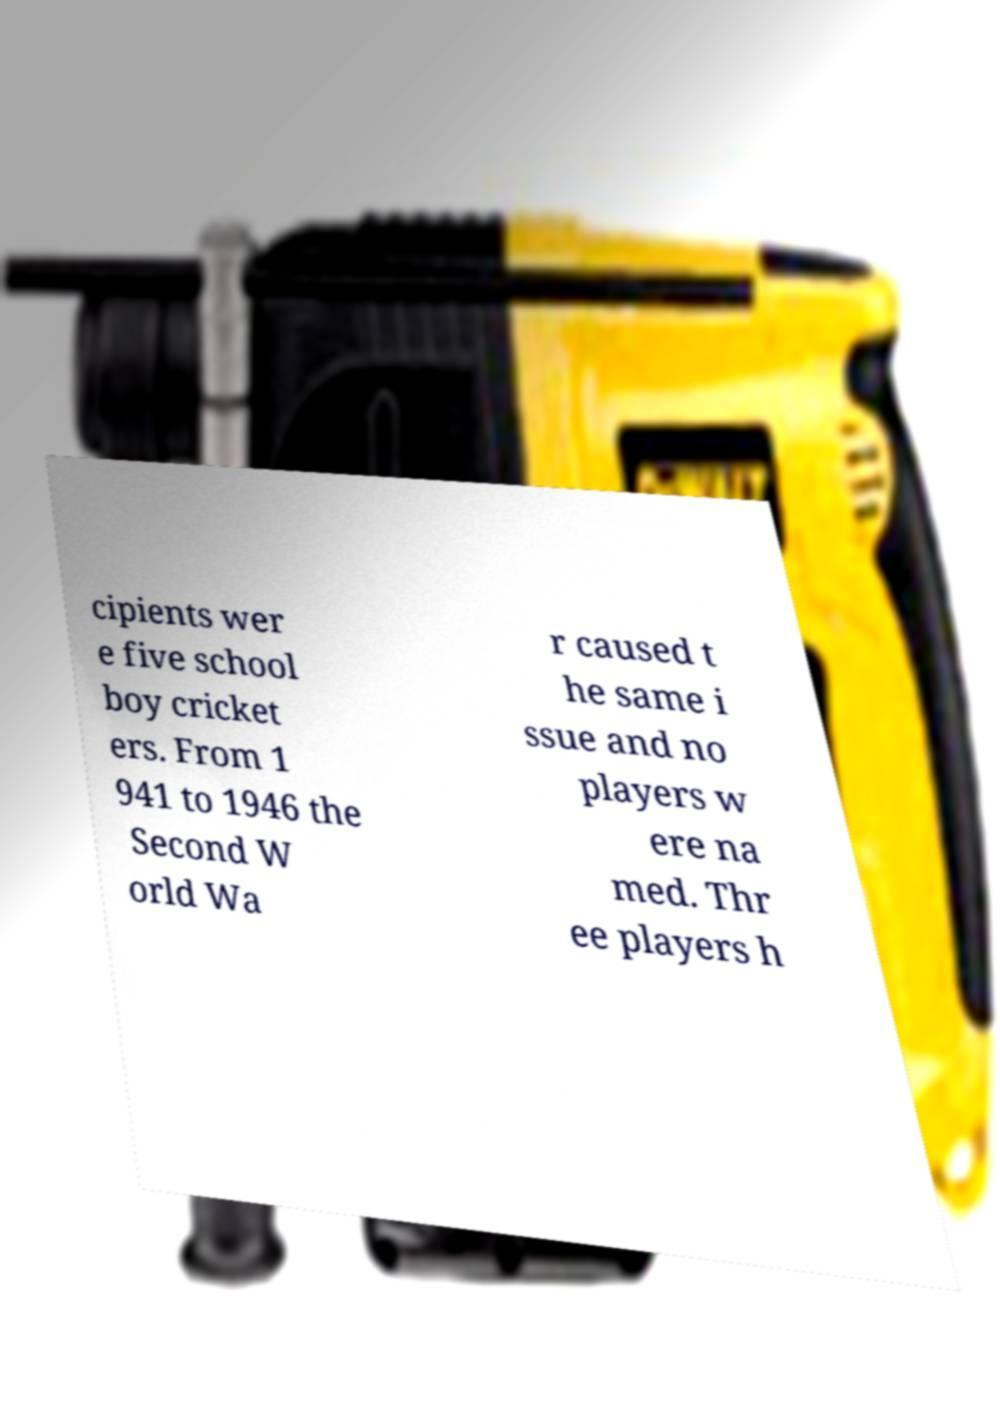There's text embedded in this image that I need extracted. Can you transcribe it verbatim? cipients wer e five school boy cricket ers. From 1 941 to 1946 the Second W orld Wa r caused t he same i ssue and no players w ere na med. Thr ee players h 